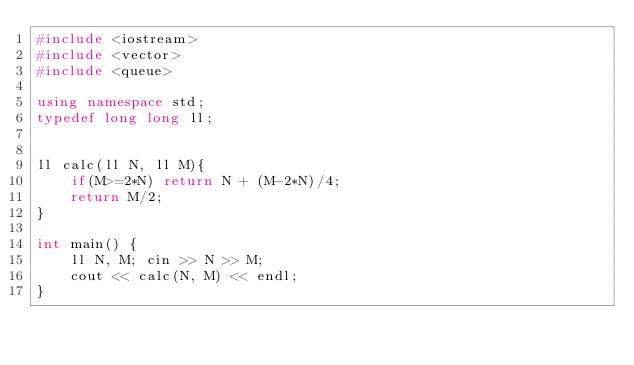<code> <loc_0><loc_0><loc_500><loc_500><_C++_>#include <iostream>
#include <vector>
#include <queue>

using namespace std;
typedef long long ll;


ll calc(ll N, ll M){
    if(M>=2*N) return N + (M-2*N)/4;
    return M/2;
}

int main() {
    ll N, M; cin >> N >> M;
    cout << calc(N, M) << endl;
}
</code> 